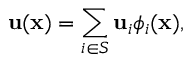<formula> <loc_0><loc_0><loc_500><loc_500>u ( x ) = \sum _ { i \in S } u _ { i } \phi _ { i } ( x ) ,</formula> 